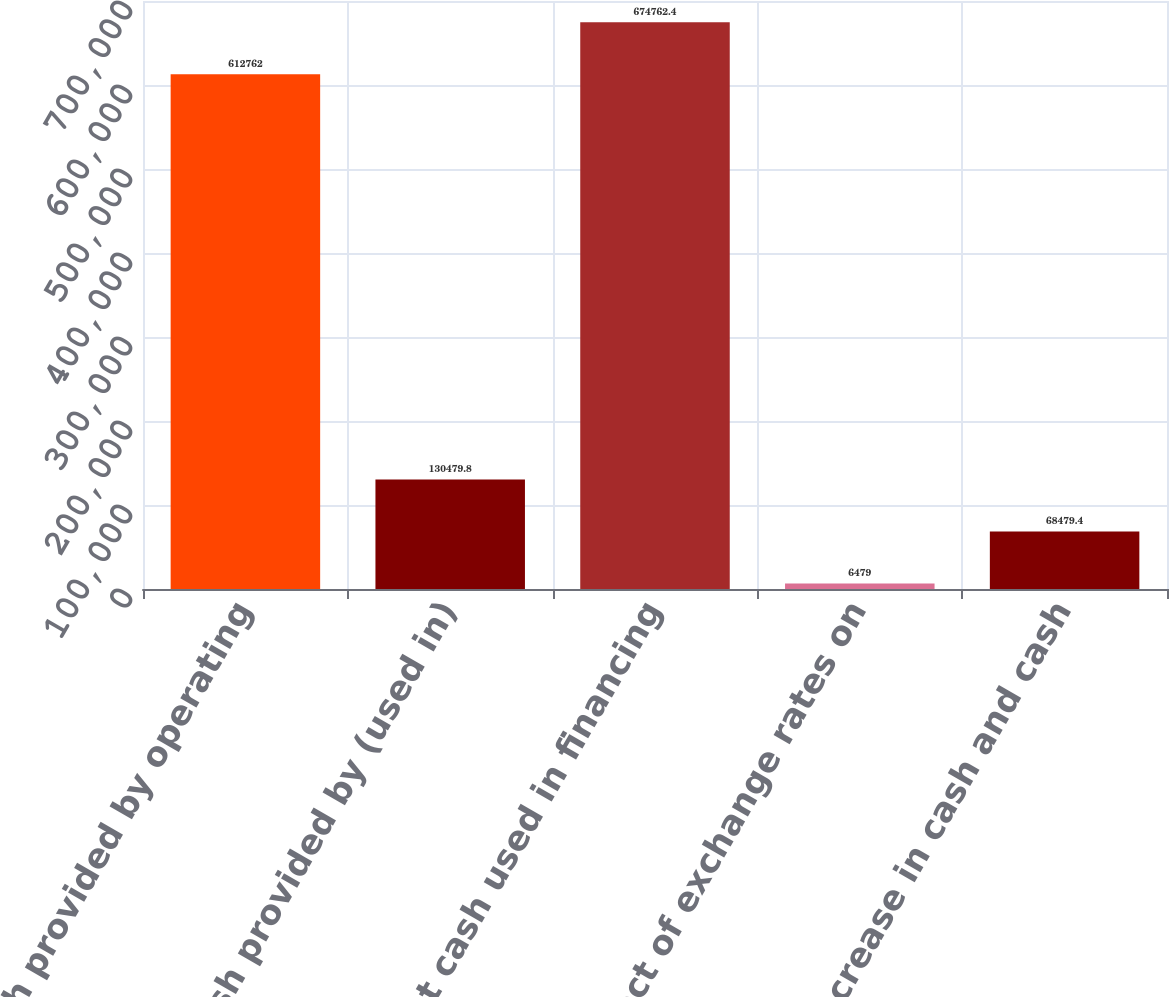Convert chart to OTSL. <chart><loc_0><loc_0><loc_500><loc_500><bar_chart><fcel>Net cash provided by operating<fcel>Net cash provided by (used in)<fcel>Net cash used in financing<fcel>Effect of exchange rates on<fcel>Net increase in cash and cash<nl><fcel>612762<fcel>130480<fcel>674762<fcel>6479<fcel>68479.4<nl></chart> 